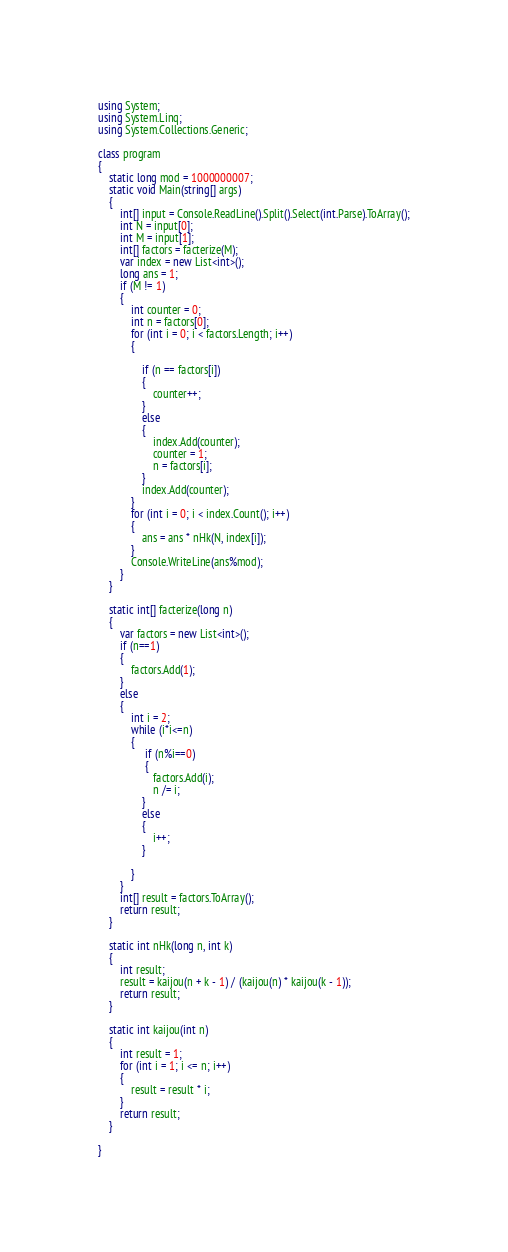<code> <loc_0><loc_0><loc_500><loc_500><_C#_>using System;
using System.Linq;
using System.Collections.Generic;

class program
{
    static long mod = 1000000007;
    static void Main(string[] args)
    {
        int[] input = Console.ReadLine().Split().Select(int.Parse).ToArray();
        int N = input[0];
        int M = input[1];
        int[] factors = facterize(M);
        var index = new List<int>();
        long ans = 1;
        if (M != 1)
        {
            int counter = 0;
            int n = factors[0];
            for (int i = 0; i < factors.Length; i++)
            {

                if (n == factors[i])
                {
                    counter++;
                }
                else
                {
                    index.Add(counter);
                    counter = 1;
                    n = factors[i];
                }
                index.Add(counter);
            }
            for (int i = 0; i < index.Count(); i++)
            {
                ans = ans * nHk(N, index[i]);
            }
            Console.WriteLine(ans%mod);
        }
    }

    static int[] facterize(long n)
    {
        var factors = new List<int>();
        if (n==1)
        {
            factors.Add(1);
        }
        else
        {
            int i = 2;
            while (i*i<=n)
            {
                 if (n%i==0)
                 {
                    factors.Add(i);
                    n /= i;
                }
                else
                {
                    i++;
                }

            }
        }
        int[] result = factors.ToArray();
        return result;
    }

    static int nHk(long n, int k)
    {
        int result;
        result = kaijou(n + k - 1) / (kaijou(n) * kaijou(k - 1));
        return result;
    }

    static int kaijou(int n)
    {
        int result = 1;
        for (int i = 1; i <= n; i++)
        {
            result = result * i;
        }
        return result;
    }

}</code> 